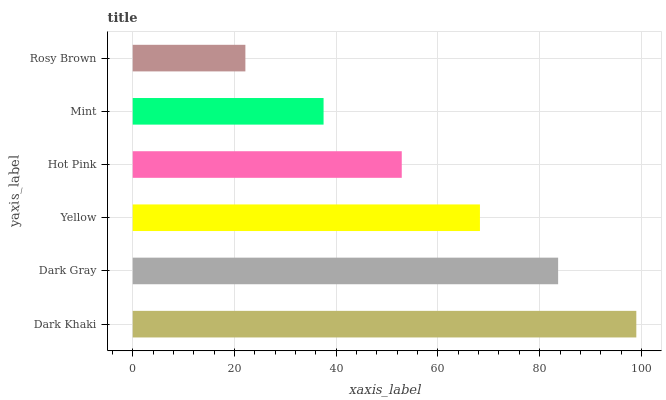Is Rosy Brown the minimum?
Answer yes or no. Yes. Is Dark Khaki the maximum?
Answer yes or no. Yes. Is Dark Gray the minimum?
Answer yes or no. No. Is Dark Gray the maximum?
Answer yes or no. No. Is Dark Khaki greater than Dark Gray?
Answer yes or no. Yes. Is Dark Gray less than Dark Khaki?
Answer yes or no. Yes. Is Dark Gray greater than Dark Khaki?
Answer yes or no. No. Is Dark Khaki less than Dark Gray?
Answer yes or no. No. Is Yellow the high median?
Answer yes or no. Yes. Is Hot Pink the low median?
Answer yes or no. Yes. Is Rosy Brown the high median?
Answer yes or no. No. Is Yellow the low median?
Answer yes or no. No. 